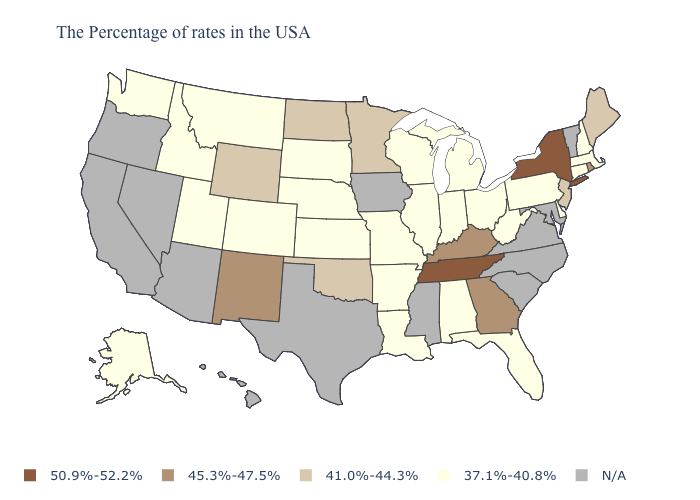Name the states that have a value in the range N/A?
Quick response, please. Vermont, Maryland, Virginia, North Carolina, South Carolina, Mississippi, Iowa, Texas, Arizona, Nevada, California, Oregon, Hawaii. What is the lowest value in states that border Connecticut?
Keep it brief. 37.1%-40.8%. What is the value of South Dakota?
Write a very short answer. 37.1%-40.8%. Among the states that border Washington , which have the lowest value?
Write a very short answer. Idaho. Name the states that have a value in the range 37.1%-40.8%?
Answer briefly. Massachusetts, New Hampshire, Connecticut, Delaware, Pennsylvania, West Virginia, Ohio, Florida, Michigan, Indiana, Alabama, Wisconsin, Illinois, Louisiana, Missouri, Arkansas, Kansas, Nebraska, South Dakota, Colorado, Utah, Montana, Idaho, Washington, Alaska. What is the highest value in states that border Arkansas?
Be succinct. 50.9%-52.2%. Does Maine have the lowest value in the USA?
Keep it brief. No. Does the first symbol in the legend represent the smallest category?
Short answer required. No. Does the map have missing data?
Quick response, please. Yes. What is the highest value in the USA?
Keep it brief. 50.9%-52.2%. Does the first symbol in the legend represent the smallest category?
Keep it brief. No. Does New York have the highest value in the Northeast?
Quick response, please. Yes. What is the lowest value in the USA?
Quick response, please. 37.1%-40.8%. What is the value of Michigan?
Quick response, please. 37.1%-40.8%. 